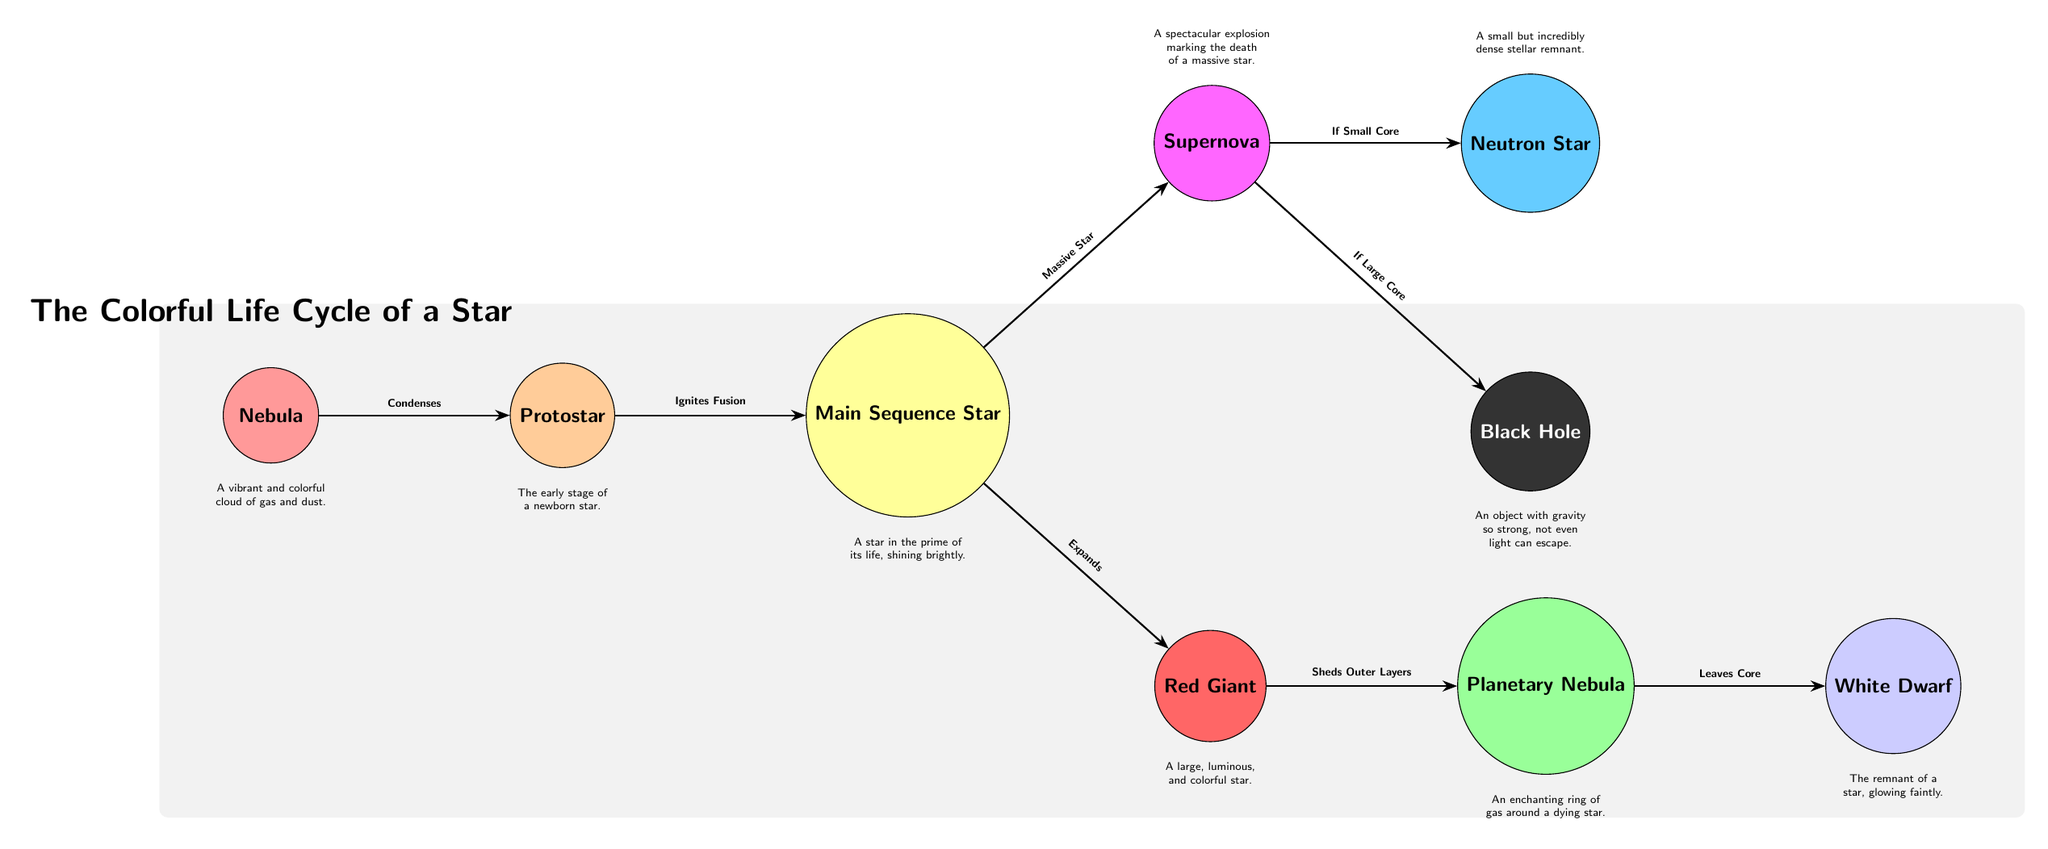What is the first stage in the life cycle of a star? The diagram shows that the first stage is represented by the "Nebula" node, which is positioned at the far left of the diagram.
Answer: Nebula What follows after the "Protostar" stage? According to the diagram, the "Protostar" directly transitions to the "Main Sequence Star" stage, as indicated by the arrow connecting these two nodes.
Answer: Main Sequence Star How many stages are there in total in the star life cycle diagram? By counting all the distinct nodes represented in the diagram, we find a total of 9 stages from "Nebula" to "Black Hole."
Answer: 9 What happens to a "Red Giant"? The diagram states that the "Red Giant" undergoes the transition where it "Sheds Outer Layers," leading to the "Planetary Nebula."
Answer: Sheds Outer Layers What is the final outcome for a massive star? The diagram indicates that a massive star, after reaching its endpoint, results in either a "Neutron Star" or a "Black Hole," depending on the size of its core after the "Supernova" explosion.
Answer: Neutron Star or Black Hole What color represents the "White Dwarf"? The node for "White Dwarf" is filled with a color that is defined in the code as a light shade of blue, which is visually represented as a soft pastel purple in the diagram.
Answer: Light blue How does a "Main Sequence Star" become a "Supernova"? The diagram outlines that a "Main Sequence Star" becomes a "Supernova" specifically if it is categorized as a "Massive Star," which suggests that mass plays a crucial role in this conversion.
Answer: Becomes a Supernova if Massive Star What type of explosion is signified in the diagram? The diagram specifies that a "Supernova" represents a spectacular explosion marking the death of a massive star, highlighting the dramatic transition from certain stages of stellar evolution.
Answer: Supernova What phenomenon is indicated by the "Planetary Nebula"? The "Planetary Nebula" is illustrated in the diagram as an enchanting ring of gas around a dying star, demonstrating its beautiful yet transient stage in the stellar life cycle.
Answer: Ring of gas around dying star 